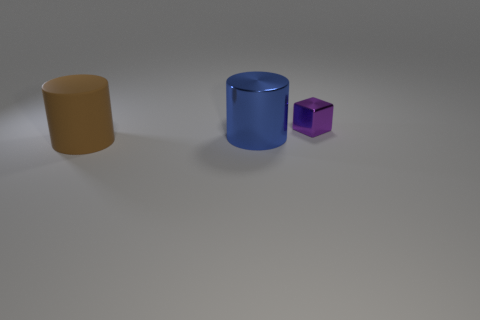There is a thing that is behind the big matte cylinder and to the left of the purple block; what shape is it?
Make the answer very short. Cylinder. Are there any other things that are the same size as the purple cube?
Make the answer very short. No. What is the color of the object that is both behind the brown rubber object and in front of the purple block?
Offer a terse response. Blue. Does the big cylinder on the right side of the brown matte cylinder have the same material as the tiny purple block?
Your response must be concise. Yes. There is a metallic block; is its color the same as the big cylinder that is behind the rubber thing?
Ensure brevity in your answer.  No. There is a brown cylinder; are there any brown matte objects right of it?
Provide a succinct answer. No. There is a object that is in front of the big blue thing; is its size the same as the metal object that is in front of the metallic cube?
Make the answer very short. Yes. Is there a gray rubber cube that has the same size as the blue object?
Offer a very short reply. No. There is a shiny object that is in front of the purple shiny block; is its shape the same as the large brown object?
Your answer should be compact. Yes. What is the material of the object that is behind the big blue shiny object?
Keep it short and to the point. Metal. 